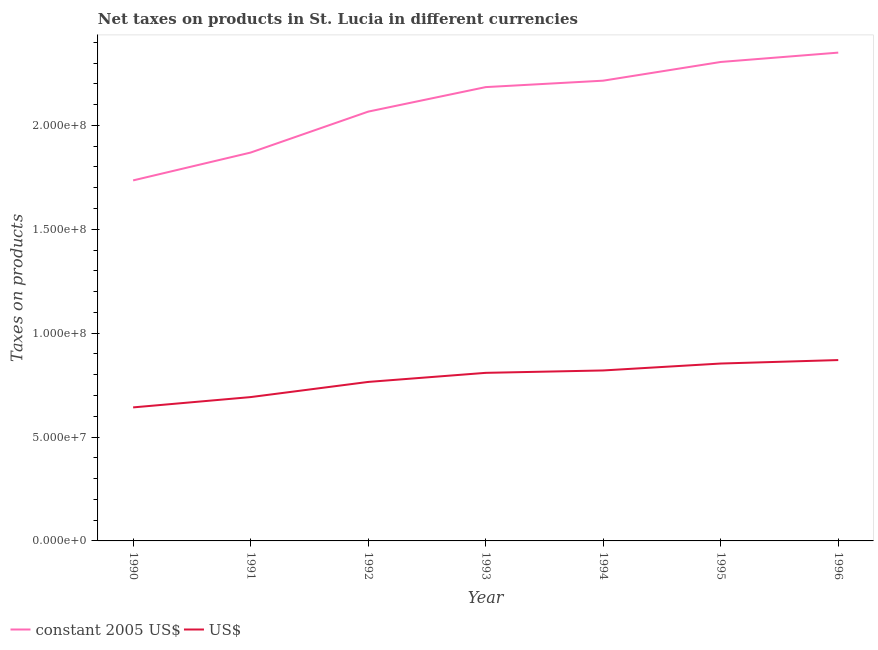Is the number of lines equal to the number of legend labels?
Provide a succinct answer. Yes. What is the net taxes in us$ in 1994?
Ensure brevity in your answer.  8.20e+07. Across all years, what is the maximum net taxes in constant 2005 us$?
Your response must be concise. 2.35e+08. Across all years, what is the minimum net taxes in us$?
Keep it short and to the point. 6.43e+07. In which year was the net taxes in constant 2005 us$ minimum?
Your answer should be compact. 1990. What is the total net taxes in us$ in the graph?
Keep it short and to the point. 5.45e+08. What is the difference between the net taxes in us$ in 1991 and that in 1995?
Your response must be concise. -1.61e+07. What is the difference between the net taxes in constant 2005 us$ in 1990 and the net taxes in us$ in 1992?
Give a very brief answer. 9.70e+07. What is the average net taxes in us$ per year?
Make the answer very short. 7.79e+07. In the year 1996, what is the difference between the net taxes in us$ and net taxes in constant 2005 us$?
Keep it short and to the point. -1.48e+08. What is the ratio of the net taxes in constant 2005 us$ in 1990 to that in 1995?
Ensure brevity in your answer.  0.75. Is the difference between the net taxes in us$ in 1992 and 1995 greater than the difference between the net taxes in constant 2005 us$ in 1992 and 1995?
Offer a very short reply. Yes. What is the difference between the highest and the second highest net taxes in us$?
Your answer should be very brief. 1.67e+06. What is the difference between the highest and the lowest net taxes in constant 2005 us$?
Your answer should be compact. 6.15e+07. In how many years, is the net taxes in us$ greater than the average net taxes in us$ taken over all years?
Offer a terse response. 4. Does the net taxes in constant 2005 us$ monotonically increase over the years?
Offer a very short reply. Yes. How many years are there in the graph?
Your answer should be compact. 7. What is the difference between two consecutive major ticks on the Y-axis?
Offer a very short reply. 5.00e+07. Are the values on the major ticks of Y-axis written in scientific E-notation?
Offer a terse response. Yes. Does the graph contain grids?
Give a very brief answer. No. Where does the legend appear in the graph?
Provide a succinct answer. Bottom left. What is the title of the graph?
Provide a succinct answer. Net taxes on products in St. Lucia in different currencies. Does "Exports of goods" appear as one of the legend labels in the graph?
Provide a succinct answer. No. What is the label or title of the X-axis?
Offer a terse response. Year. What is the label or title of the Y-axis?
Offer a terse response. Taxes on products. What is the Taxes on products of constant 2005 US$ in 1990?
Provide a succinct answer. 1.74e+08. What is the Taxes on products in US$ in 1990?
Make the answer very short. 6.43e+07. What is the Taxes on products in constant 2005 US$ in 1991?
Make the answer very short. 1.87e+08. What is the Taxes on products of US$ in 1991?
Ensure brevity in your answer.  6.92e+07. What is the Taxes on products in constant 2005 US$ in 1992?
Your answer should be compact. 2.07e+08. What is the Taxes on products of US$ in 1992?
Offer a terse response. 7.65e+07. What is the Taxes on products in constant 2005 US$ in 1993?
Make the answer very short. 2.18e+08. What is the Taxes on products in US$ in 1993?
Provide a short and direct response. 8.09e+07. What is the Taxes on products of constant 2005 US$ in 1994?
Make the answer very short. 2.22e+08. What is the Taxes on products in US$ in 1994?
Your answer should be compact. 8.20e+07. What is the Taxes on products of constant 2005 US$ in 1995?
Your response must be concise. 2.30e+08. What is the Taxes on products in US$ in 1995?
Your answer should be compact. 8.54e+07. What is the Taxes on products of constant 2005 US$ in 1996?
Your answer should be very brief. 2.35e+08. What is the Taxes on products of US$ in 1996?
Keep it short and to the point. 8.70e+07. Across all years, what is the maximum Taxes on products in constant 2005 US$?
Keep it short and to the point. 2.35e+08. Across all years, what is the maximum Taxes on products in US$?
Offer a very short reply. 8.70e+07. Across all years, what is the minimum Taxes on products in constant 2005 US$?
Your answer should be very brief. 1.74e+08. Across all years, what is the minimum Taxes on products of US$?
Provide a short and direct response. 6.43e+07. What is the total Taxes on products in constant 2005 US$ in the graph?
Provide a succinct answer. 1.47e+09. What is the total Taxes on products in US$ in the graph?
Provide a succinct answer. 5.45e+08. What is the difference between the Taxes on products of constant 2005 US$ in 1990 and that in 1991?
Your answer should be very brief. -1.34e+07. What is the difference between the Taxes on products of US$ in 1990 and that in 1991?
Make the answer very short. -4.96e+06. What is the difference between the Taxes on products in constant 2005 US$ in 1990 and that in 1992?
Ensure brevity in your answer.  -3.31e+07. What is the difference between the Taxes on products of US$ in 1990 and that in 1992?
Offer a very short reply. -1.23e+07. What is the difference between the Taxes on products in constant 2005 US$ in 1990 and that in 1993?
Your answer should be very brief. -4.49e+07. What is the difference between the Taxes on products of US$ in 1990 and that in 1993?
Keep it short and to the point. -1.66e+07. What is the difference between the Taxes on products in constant 2005 US$ in 1990 and that in 1994?
Provide a short and direct response. -4.80e+07. What is the difference between the Taxes on products of US$ in 1990 and that in 1994?
Your answer should be very brief. -1.78e+07. What is the difference between the Taxes on products in constant 2005 US$ in 1990 and that in 1995?
Your answer should be compact. -5.70e+07. What is the difference between the Taxes on products of US$ in 1990 and that in 1995?
Make the answer very short. -2.11e+07. What is the difference between the Taxes on products in constant 2005 US$ in 1990 and that in 1996?
Keep it short and to the point. -6.15e+07. What is the difference between the Taxes on products of US$ in 1990 and that in 1996?
Give a very brief answer. -2.28e+07. What is the difference between the Taxes on products in constant 2005 US$ in 1991 and that in 1992?
Offer a terse response. -1.97e+07. What is the difference between the Taxes on products of US$ in 1991 and that in 1992?
Provide a succinct answer. -7.30e+06. What is the difference between the Taxes on products of constant 2005 US$ in 1991 and that in 1993?
Provide a succinct answer. -3.15e+07. What is the difference between the Taxes on products in US$ in 1991 and that in 1993?
Offer a very short reply. -1.17e+07. What is the difference between the Taxes on products in constant 2005 US$ in 1991 and that in 1994?
Provide a succinct answer. -3.46e+07. What is the difference between the Taxes on products of US$ in 1991 and that in 1994?
Offer a very short reply. -1.28e+07. What is the difference between the Taxes on products of constant 2005 US$ in 1991 and that in 1995?
Provide a short and direct response. -4.36e+07. What is the difference between the Taxes on products of US$ in 1991 and that in 1995?
Ensure brevity in your answer.  -1.61e+07. What is the difference between the Taxes on products of constant 2005 US$ in 1991 and that in 1996?
Your response must be concise. -4.81e+07. What is the difference between the Taxes on products of US$ in 1991 and that in 1996?
Provide a short and direct response. -1.78e+07. What is the difference between the Taxes on products in constant 2005 US$ in 1992 and that in 1993?
Your answer should be compact. -1.18e+07. What is the difference between the Taxes on products in US$ in 1992 and that in 1993?
Offer a very short reply. -4.37e+06. What is the difference between the Taxes on products of constant 2005 US$ in 1992 and that in 1994?
Provide a short and direct response. -1.49e+07. What is the difference between the Taxes on products of US$ in 1992 and that in 1994?
Your answer should be very brief. -5.52e+06. What is the difference between the Taxes on products in constant 2005 US$ in 1992 and that in 1995?
Give a very brief answer. -2.39e+07. What is the difference between the Taxes on products of US$ in 1992 and that in 1995?
Ensure brevity in your answer.  -8.85e+06. What is the difference between the Taxes on products of constant 2005 US$ in 1992 and that in 1996?
Make the answer very short. -2.84e+07. What is the difference between the Taxes on products in US$ in 1992 and that in 1996?
Keep it short and to the point. -1.05e+07. What is the difference between the Taxes on products of constant 2005 US$ in 1993 and that in 1994?
Offer a very short reply. -3.10e+06. What is the difference between the Taxes on products of US$ in 1993 and that in 1994?
Keep it short and to the point. -1.15e+06. What is the difference between the Taxes on products of constant 2005 US$ in 1993 and that in 1995?
Your answer should be very brief. -1.21e+07. What is the difference between the Taxes on products in US$ in 1993 and that in 1995?
Give a very brief answer. -4.48e+06. What is the difference between the Taxes on products of constant 2005 US$ in 1993 and that in 1996?
Keep it short and to the point. -1.66e+07. What is the difference between the Taxes on products in US$ in 1993 and that in 1996?
Your response must be concise. -6.15e+06. What is the difference between the Taxes on products in constant 2005 US$ in 1994 and that in 1995?
Make the answer very short. -9.00e+06. What is the difference between the Taxes on products of US$ in 1994 and that in 1995?
Your answer should be very brief. -3.33e+06. What is the difference between the Taxes on products of constant 2005 US$ in 1994 and that in 1996?
Provide a short and direct response. -1.35e+07. What is the difference between the Taxes on products in US$ in 1994 and that in 1996?
Provide a short and direct response. -5.00e+06. What is the difference between the Taxes on products in constant 2005 US$ in 1995 and that in 1996?
Give a very brief answer. -4.50e+06. What is the difference between the Taxes on products of US$ in 1995 and that in 1996?
Your answer should be compact. -1.67e+06. What is the difference between the Taxes on products in constant 2005 US$ in 1990 and the Taxes on products in US$ in 1991?
Ensure brevity in your answer.  1.04e+08. What is the difference between the Taxes on products in constant 2005 US$ in 1990 and the Taxes on products in US$ in 1992?
Make the answer very short. 9.70e+07. What is the difference between the Taxes on products of constant 2005 US$ in 1990 and the Taxes on products of US$ in 1993?
Make the answer very short. 9.26e+07. What is the difference between the Taxes on products of constant 2005 US$ in 1990 and the Taxes on products of US$ in 1994?
Provide a short and direct response. 9.15e+07. What is the difference between the Taxes on products in constant 2005 US$ in 1990 and the Taxes on products in US$ in 1995?
Give a very brief answer. 8.81e+07. What is the difference between the Taxes on products in constant 2005 US$ in 1990 and the Taxes on products in US$ in 1996?
Provide a succinct answer. 8.65e+07. What is the difference between the Taxes on products in constant 2005 US$ in 1991 and the Taxes on products in US$ in 1992?
Your answer should be very brief. 1.10e+08. What is the difference between the Taxes on products in constant 2005 US$ in 1991 and the Taxes on products in US$ in 1993?
Offer a very short reply. 1.06e+08. What is the difference between the Taxes on products of constant 2005 US$ in 1991 and the Taxes on products of US$ in 1994?
Make the answer very short. 1.05e+08. What is the difference between the Taxes on products in constant 2005 US$ in 1991 and the Taxes on products in US$ in 1995?
Provide a short and direct response. 1.02e+08. What is the difference between the Taxes on products of constant 2005 US$ in 1991 and the Taxes on products of US$ in 1996?
Your answer should be compact. 9.99e+07. What is the difference between the Taxes on products of constant 2005 US$ in 1992 and the Taxes on products of US$ in 1993?
Provide a succinct answer. 1.26e+08. What is the difference between the Taxes on products in constant 2005 US$ in 1992 and the Taxes on products in US$ in 1994?
Keep it short and to the point. 1.25e+08. What is the difference between the Taxes on products of constant 2005 US$ in 1992 and the Taxes on products of US$ in 1995?
Offer a very short reply. 1.21e+08. What is the difference between the Taxes on products in constant 2005 US$ in 1992 and the Taxes on products in US$ in 1996?
Offer a terse response. 1.20e+08. What is the difference between the Taxes on products of constant 2005 US$ in 1993 and the Taxes on products of US$ in 1994?
Give a very brief answer. 1.36e+08. What is the difference between the Taxes on products in constant 2005 US$ in 1993 and the Taxes on products in US$ in 1995?
Your answer should be compact. 1.33e+08. What is the difference between the Taxes on products in constant 2005 US$ in 1993 and the Taxes on products in US$ in 1996?
Ensure brevity in your answer.  1.31e+08. What is the difference between the Taxes on products of constant 2005 US$ in 1994 and the Taxes on products of US$ in 1995?
Provide a succinct answer. 1.36e+08. What is the difference between the Taxes on products of constant 2005 US$ in 1994 and the Taxes on products of US$ in 1996?
Offer a terse response. 1.34e+08. What is the difference between the Taxes on products of constant 2005 US$ in 1995 and the Taxes on products of US$ in 1996?
Provide a succinct answer. 1.43e+08. What is the average Taxes on products of constant 2005 US$ per year?
Offer a terse response. 2.10e+08. What is the average Taxes on products in US$ per year?
Provide a short and direct response. 7.79e+07. In the year 1990, what is the difference between the Taxes on products of constant 2005 US$ and Taxes on products of US$?
Provide a short and direct response. 1.09e+08. In the year 1991, what is the difference between the Taxes on products in constant 2005 US$ and Taxes on products in US$?
Provide a succinct answer. 1.18e+08. In the year 1992, what is the difference between the Taxes on products in constant 2005 US$ and Taxes on products in US$?
Keep it short and to the point. 1.30e+08. In the year 1993, what is the difference between the Taxes on products in constant 2005 US$ and Taxes on products in US$?
Ensure brevity in your answer.  1.38e+08. In the year 1994, what is the difference between the Taxes on products of constant 2005 US$ and Taxes on products of US$?
Give a very brief answer. 1.39e+08. In the year 1995, what is the difference between the Taxes on products of constant 2005 US$ and Taxes on products of US$?
Your response must be concise. 1.45e+08. In the year 1996, what is the difference between the Taxes on products in constant 2005 US$ and Taxes on products in US$?
Give a very brief answer. 1.48e+08. What is the ratio of the Taxes on products of constant 2005 US$ in 1990 to that in 1991?
Ensure brevity in your answer.  0.93. What is the ratio of the Taxes on products in US$ in 1990 to that in 1991?
Provide a succinct answer. 0.93. What is the ratio of the Taxes on products of constant 2005 US$ in 1990 to that in 1992?
Give a very brief answer. 0.84. What is the ratio of the Taxes on products of US$ in 1990 to that in 1992?
Keep it short and to the point. 0.84. What is the ratio of the Taxes on products in constant 2005 US$ in 1990 to that in 1993?
Your answer should be compact. 0.79. What is the ratio of the Taxes on products of US$ in 1990 to that in 1993?
Keep it short and to the point. 0.79. What is the ratio of the Taxes on products of constant 2005 US$ in 1990 to that in 1994?
Your response must be concise. 0.78. What is the ratio of the Taxes on products in US$ in 1990 to that in 1994?
Your response must be concise. 0.78. What is the ratio of the Taxes on products in constant 2005 US$ in 1990 to that in 1995?
Provide a short and direct response. 0.75. What is the ratio of the Taxes on products in US$ in 1990 to that in 1995?
Your answer should be compact. 0.75. What is the ratio of the Taxes on products in constant 2005 US$ in 1990 to that in 1996?
Your response must be concise. 0.74. What is the ratio of the Taxes on products in US$ in 1990 to that in 1996?
Your answer should be compact. 0.74. What is the ratio of the Taxes on products in constant 2005 US$ in 1991 to that in 1992?
Offer a terse response. 0.9. What is the ratio of the Taxes on products in US$ in 1991 to that in 1992?
Provide a succinct answer. 0.9. What is the ratio of the Taxes on products of constant 2005 US$ in 1991 to that in 1993?
Offer a terse response. 0.86. What is the ratio of the Taxes on products of US$ in 1991 to that in 1993?
Your response must be concise. 0.86. What is the ratio of the Taxes on products of constant 2005 US$ in 1991 to that in 1994?
Your answer should be compact. 0.84. What is the ratio of the Taxes on products in US$ in 1991 to that in 1994?
Provide a succinct answer. 0.84. What is the ratio of the Taxes on products of constant 2005 US$ in 1991 to that in 1995?
Give a very brief answer. 0.81. What is the ratio of the Taxes on products in US$ in 1991 to that in 1995?
Offer a very short reply. 0.81. What is the ratio of the Taxes on products of constant 2005 US$ in 1991 to that in 1996?
Keep it short and to the point. 0.8. What is the ratio of the Taxes on products in US$ in 1991 to that in 1996?
Provide a short and direct response. 0.8. What is the ratio of the Taxes on products of constant 2005 US$ in 1992 to that in 1993?
Your response must be concise. 0.95. What is the ratio of the Taxes on products of US$ in 1992 to that in 1993?
Give a very brief answer. 0.95. What is the ratio of the Taxes on products of constant 2005 US$ in 1992 to that in 1994?
Your response must be concise. 0.93. What is the ratio of the Taxes on products in US$ in 1992 to that in 1994?
Provide a succinct answer. 0.93. What is the ratio of the Taxes on products in constant 2005 US$ in 1992 to that in 1995?
Your answer should be compact. 0.9. What is the ratio of the Taxes on products of US$ in 1992 to that in 1995?
Provide a succinct answer. 0.9. What is the ratio of the Taxes on products of constant 2005 US$ in 1992 to that in 1996?
Give a very brief answer. 0.88. What is the ratio of the Taxes on products of US$ in 1992 to that in 1996?
Your response must be concise. 0.88. What is the ratio of the Taxes on products of constant 2005 US$ in 1993 to that in 1994?
Provide a short and direct response. 0.99. What is the ratio of the Taxes on products in US$ in 1993 to that in 1994?
Give a very brief answer. 0.99. What is the ratio of the Taxes on products of constant 2005 US$ in 1993 to that in 1995?
Ensure brevity in your answer.  0.95. What is the ratio of the Taxes on products of US$ in 1993 to that in 1995?
Provide a short and direct response. 0.95. What is the ratio of the Taxes on products of constant 2005 US$ in 1993 to that in 1996?
Ensure brevity in your answer.  0.93. What is the ratio of the Taxes on products of US$ in 1993 to that in 1996?
Ensure brevity in your answer.  0.93. What is the ratio of the Taxes on products in constant 2005 US$ in 1994 to that in 1996?
Provide a short and direct response. 0.94. What is the ratio of the Taxes on products of US$ in 1994 to that in 1996?
Provide a short and direct response. 0.94. What is the ratio of the Taxes on products of constant 2005 US$ in 1995 to that in 1996?
Provide a short and direct response. 0.98. What is the ratio of the Taxes on products in US$ in 1995 to that in 1996?
Your answer should be very brief. 0.98. What is the difference between the highest and the second highest Taxes on products of constant 2005 US$?
Offer a terse response. 4.50e+06. What is the difference between the highest and the second highest Taxes on products of US$?
Your answer should be very brief. 1.67e+06. What is the difference between the highest and the lowest Taxes on products in constant 2005 US$?
Offer a very short reply. 6.15e+07. What is the difference between the highest and the lowest Taxes on products of US$?
Your response must be concise. 2.28e+07. 